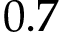<formula> <loc_0><loc_0><loc_500><loc_500>0 . 7</formula> 